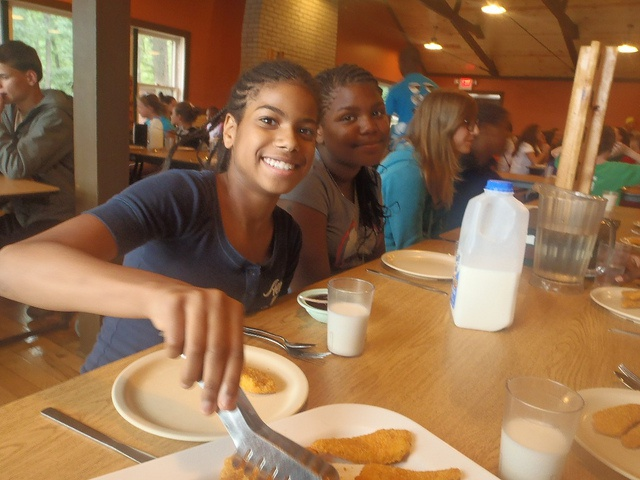Describe the objects in this image and their specific colors. I can see dining table in gray and tan tones, people in gray, black, tan, and maroon tones, people in gray, maroon, black, and brown tones, people in gray, maroon, teal, and black tones, and people in gray, maroon, and black tones in this image. 